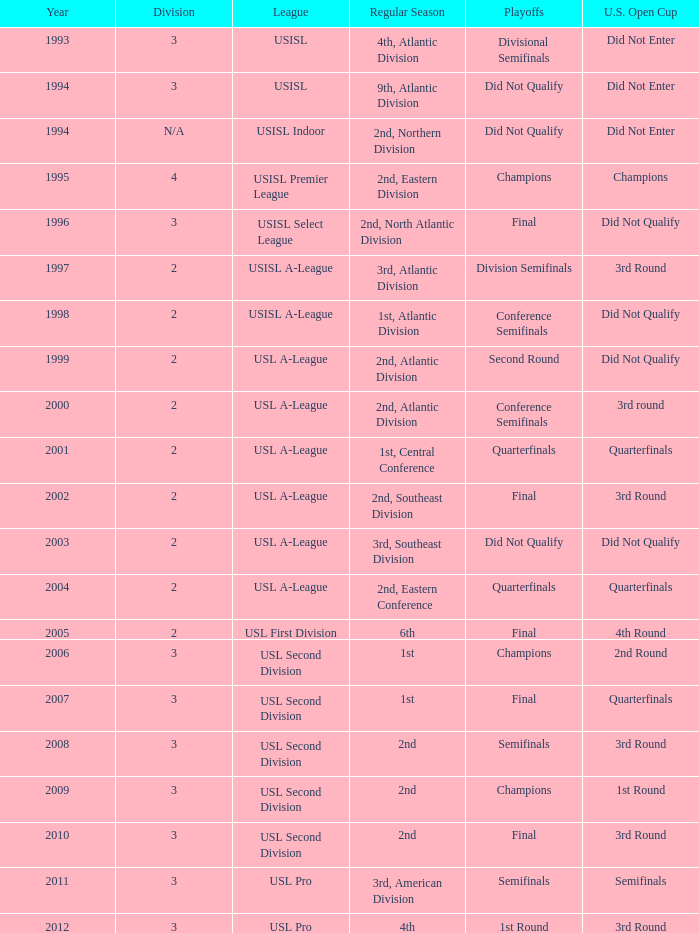What is the u.s. open cup standing for the regular season of 4th, atlantic division? Did Not Enter. 